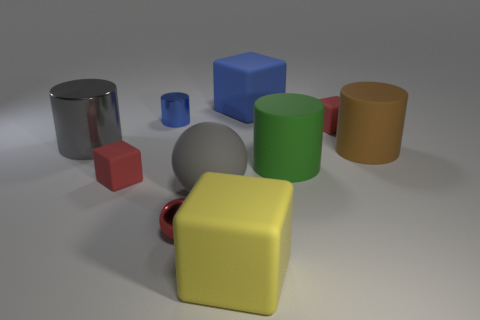What colors are present in the image? The image contains a variety of colors, including silver, blue, red, yellow, green, and orange.  Do these objects have textures or are they smooth? All objects in the image have a smooth surface with a matte or slightly reflective finish. None of the visible objects have a textured surface. 